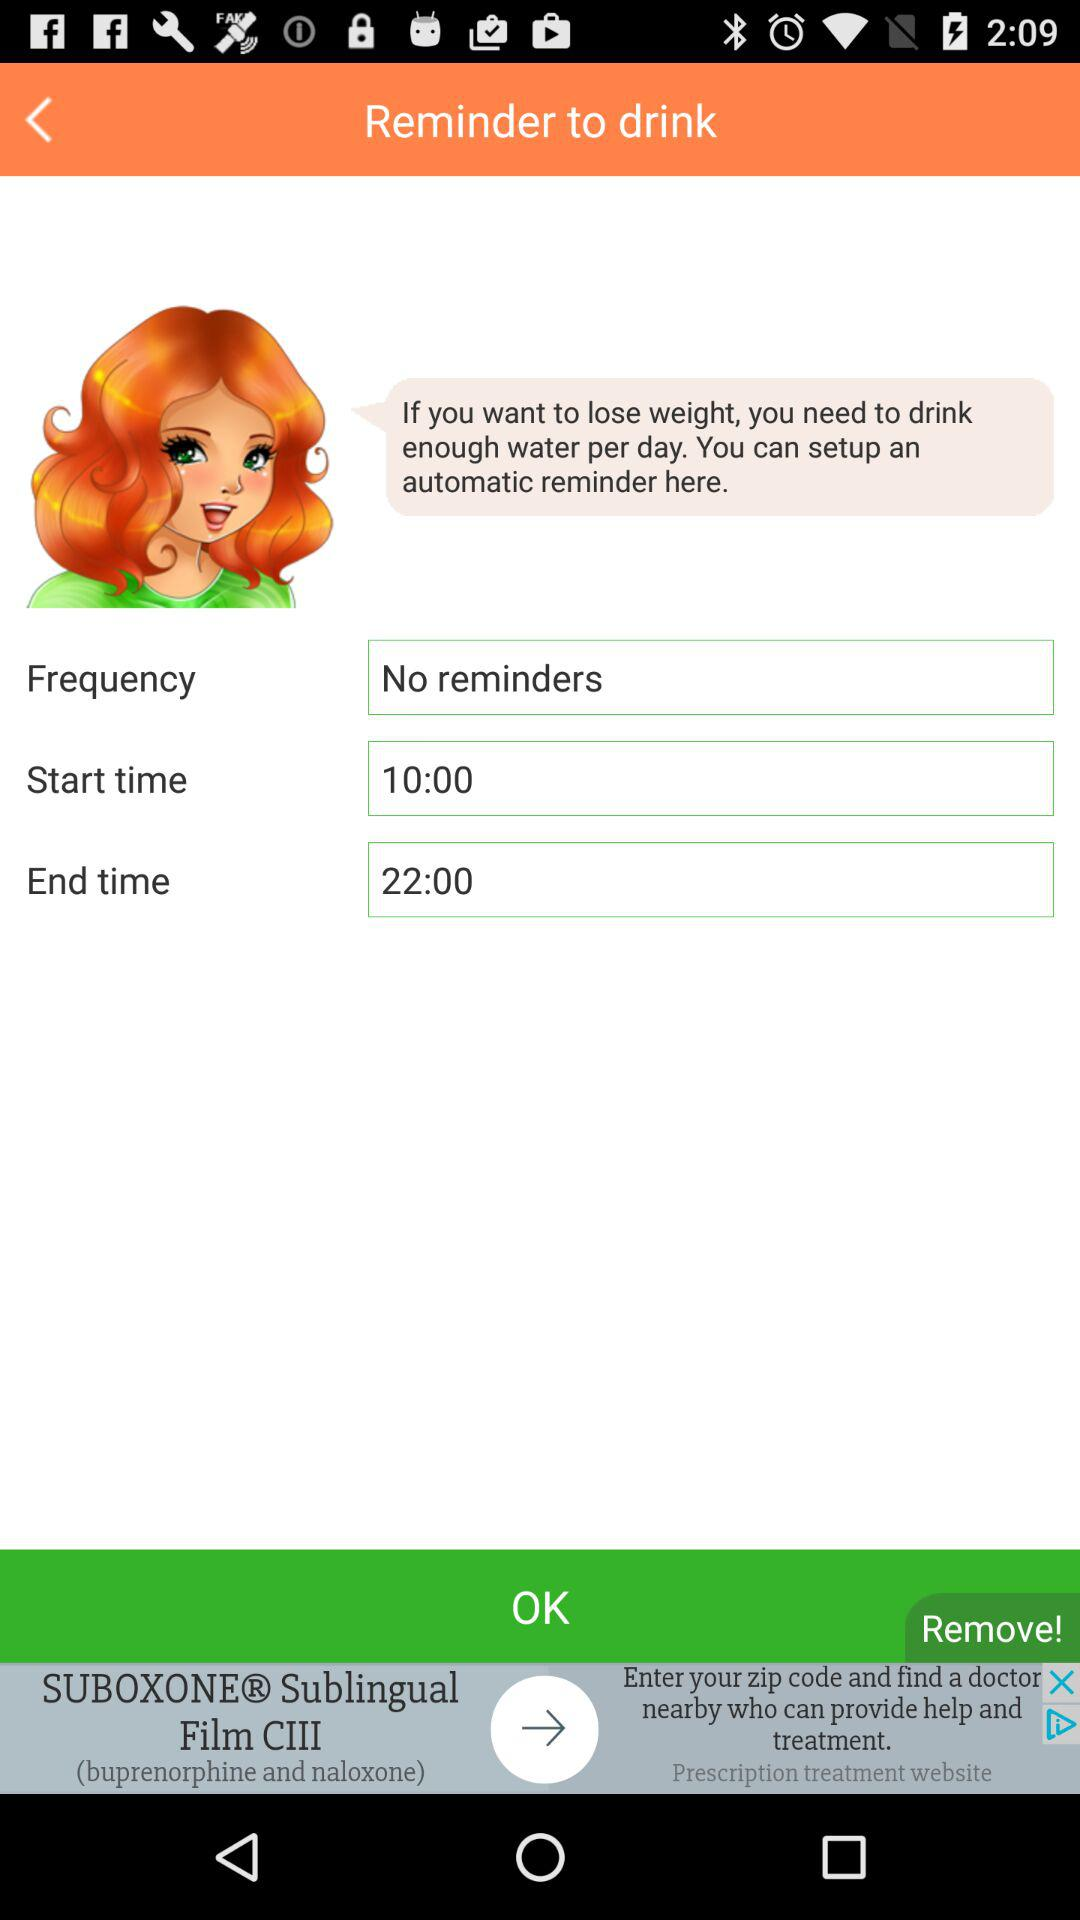What type of time is 22:00? 22:00 is the end time. 